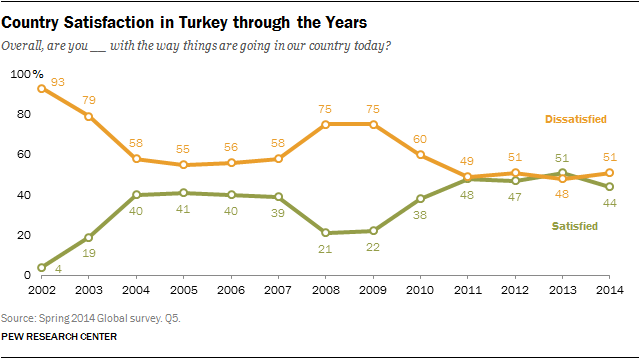List a handful of essential elements in this visual. In 2013, the value of the orange data point was smaller than the value of the green data point. In 2014, the value of the "Satisfied" graph was 44. 